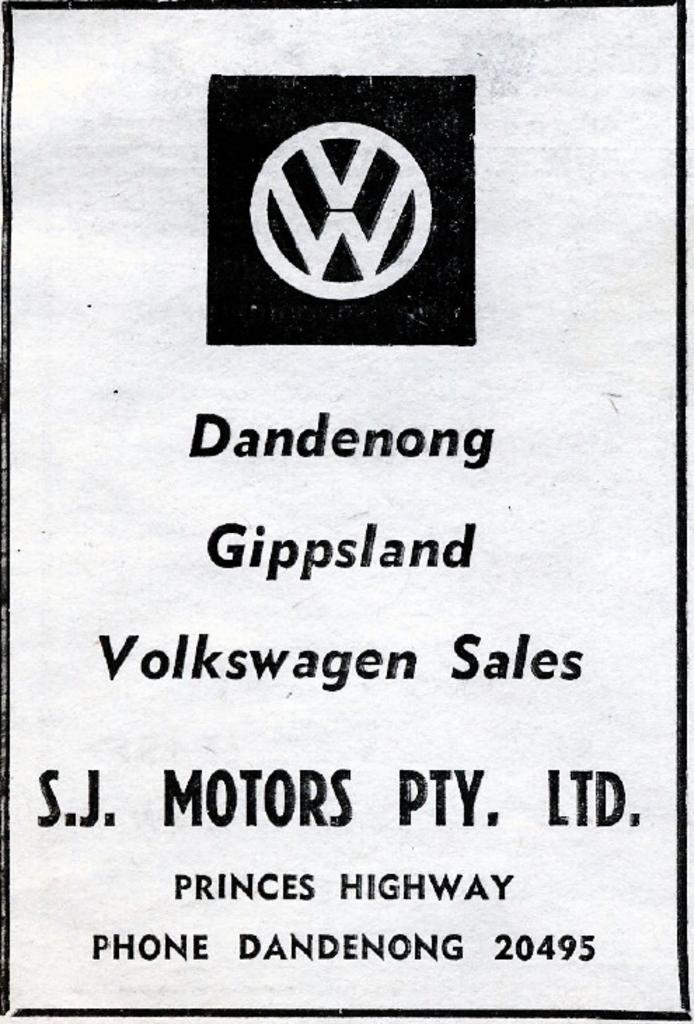<image>
Write a terse but informative summary of the picture. Paper for Volkswagen that has the number 20495 on the bottom. 